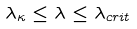<formula> <loc_0><loc_0><loc_500><loc_500>\lambda _ { \kappa } \leq \lambda \leq \lambda _ { c r i t }</formula> 